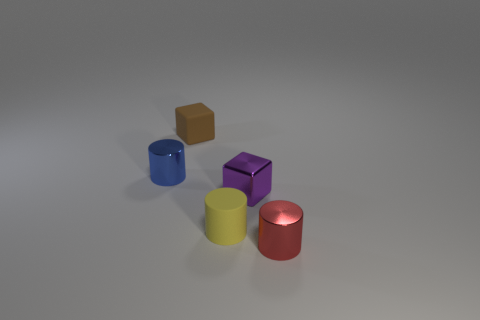Is the number of big cyan metallic cylinders greater than the number of tiny brown cubes?
Provide a succinct answer. No. Does the metal cylinder that is to the left of the tiny red object have the same color as the small cylinder that is right of the tiny yellow cylinder?
Provide a short and direct response. No. Does the small thing that is behind the small blue thing have the same material as the cube that is to the right of the matte block?
Your response must be concise. No. What number of metal cylinders have the same size as the brown cube?
Ensure brevity in your answer.  2. Are there fewer small yellow cylinders than big brown metal blocks?
Your answer should be very brief. No. What is the shape of the object that is in front of the rubber thing in front of the brown block?
Your response must be concise. Cylinder. There is a matte object that is the same size as the brown matte block; what is its shape?
Offer a very short reply. Cylinder. Is there another brown matte object of the same shape as the brown rubber thing?
Keep it short and to the point. No. What is the yellow cylinder made of?
Keep it short and to the point. Rubber. Are there any small blue things to the right of the brown object?
Offer a very short reply. No. 